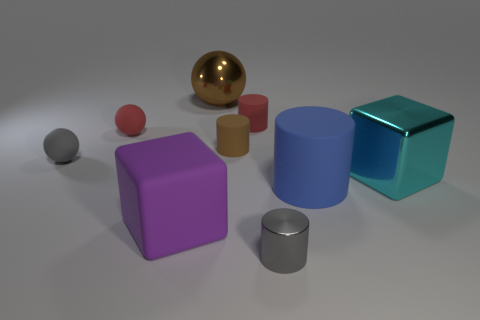Can you tell me which objects in the picture are spherical and what colors they are? Sure, in the image, there are two spherical objects. One is red, and the other is grey. 